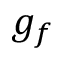Convert formula to latex. <formula><loc_0><loc_0><loc_500><loc_500>g _ { f }</formula> 